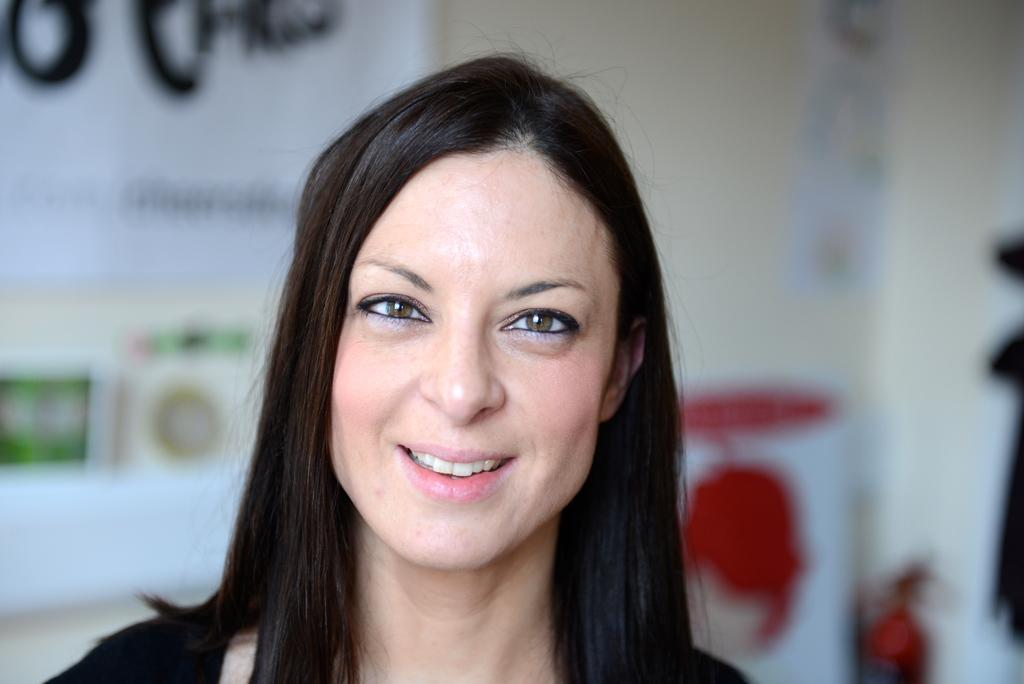Who is present in the image? There is a woman in the image. What is the woman's expression? The woman is smiling. What can be seen attached to the wall in the image? There is a banner in the image, and it is attached to a wall. How would you describe the banner in the image? The banner appears to be an object. What type of brass instrument is the woman playing in the image? There is no brass instrument present in the image; the woman is simply smiling. 